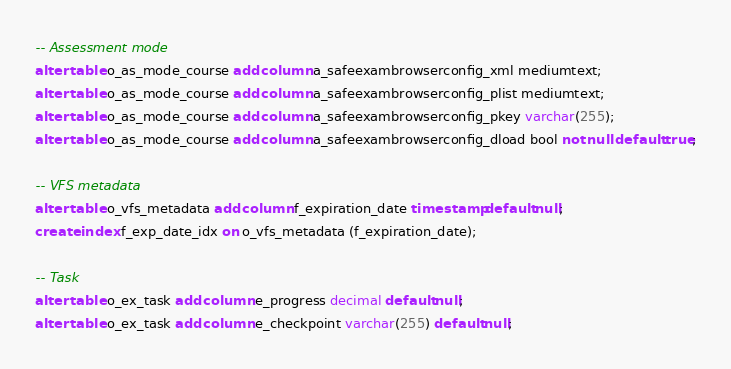<code> <loc_0><loc_0><loc_500><loc_500><_SQL_>-- Assessment mode
alter table o_as_mode_course add column a_safeexambrowserconfig_xml mediumtext;
alter table o_as_mode_course add column a_safeexambrowserconfig_plist mediumtext;
alter table o_as_mode_course add column a_safeexambrowserconfig_pkey varchar(255);
alter table o_as_mode_course add column a_safeexambrowserconfig_dload bool not null default true;

-- VFS metadata
alter table o_vfs_metadata add column f_expiration_date timestamp default null;
create index f_exp_date_idx on o_vfs_metadata (f_expiration_date);

-- Task
alter table o_ex_task add column e_progress decimal default null;
alter table o_ex_task add column e_checkpoint varchar(255) default null;
</code> 